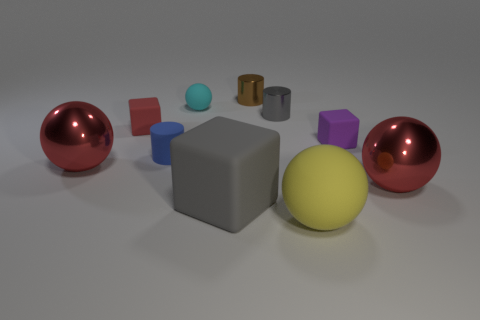Are there any other things that are made of the same material as the small blue cylinder?
Your answer should be compact. Yes. Are there any large rubber cubes behind the thing that is behind the cyan rubber thing?
Keep it short and to the point. No. There is a blue thing; what number of red spheres are behind it?
Your response must be concise. 0. How many other objects are there of the same color as the large rubber block?
Make the answer very short. 1. Are there fewer red cubes in front of the red rubber cube than large red balls behind the small gray metal thing?
Give a very brief answer. No. What number of things are either large red metallic objects to the left of the blue cylinder or large objects?
Provide a succinct answer. 4. Do the gray metal object and the metal sphere to the right of the purple rubber block have the same size?
Provide a short and direct response. No. What size is the blue matte thing that is the same shape as the small gray metal object?
Your response must be concise. Small. How many red spheres are left of the large red object in front of the big ball that is left of the gray rubber cube?
Your response must be concise. 1. How many blocks are gray objects or tiny purple matte things?
Provide a short and direct response. 2. 